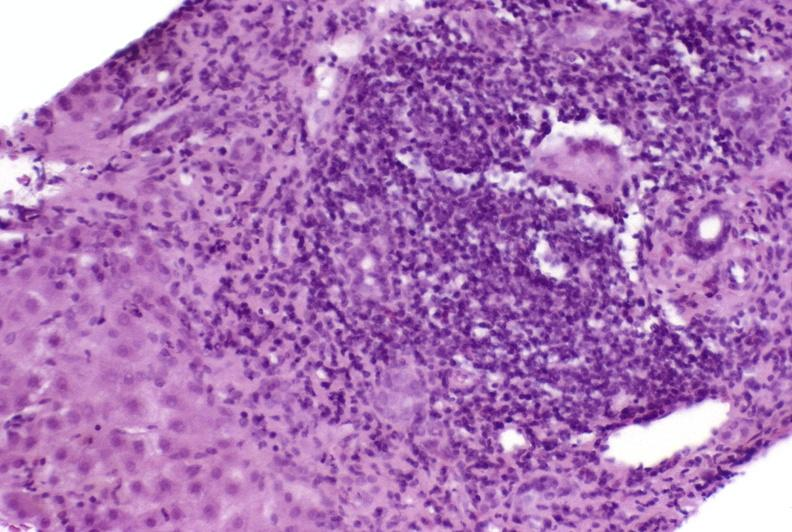s liver present?
Answer the question using a single word or phrase. Yes 